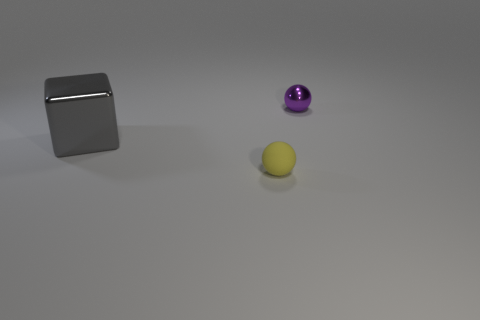How many things are either spheres or objects behind the matte thing?
Your answer should be very brief. 3. What number of small rubber objects are the same shape as the purple shiny thing?
Offer a very short reply. 1. There is a yellow sphere that is the same size as the purple sphere; what is it made of?
Give a very brief answer. Rubber. How big is the purple thing that is to the right of the tiny thing in front of the sphere on the right side of the small yellow rubber ball?
Offer a very short reply. Small. How many brown objects are either large spheres or metallic objects?
Provide a short and direct response. 0. How many metal spheres are the same size as the cube?
Make the answer very short. 0. Are the tiny object that is left of the tiny metallic thing and the purple thing made of the same material?
Offer a very short reply. No. There is a tiny thing that is behind the gray block; are there any small rubber things that are on the left side of it?
Your answer should be very brief. Yes. What material is the small yellow thing that is the same shape as the tiny purple thing?
Make the answer very short. Rubber. Are there more large shiny things that are in front of the tiny shiny sphere than tiny yellow balls in front of the small yellow rubber thing?
Offer a very short reply. Yes. 